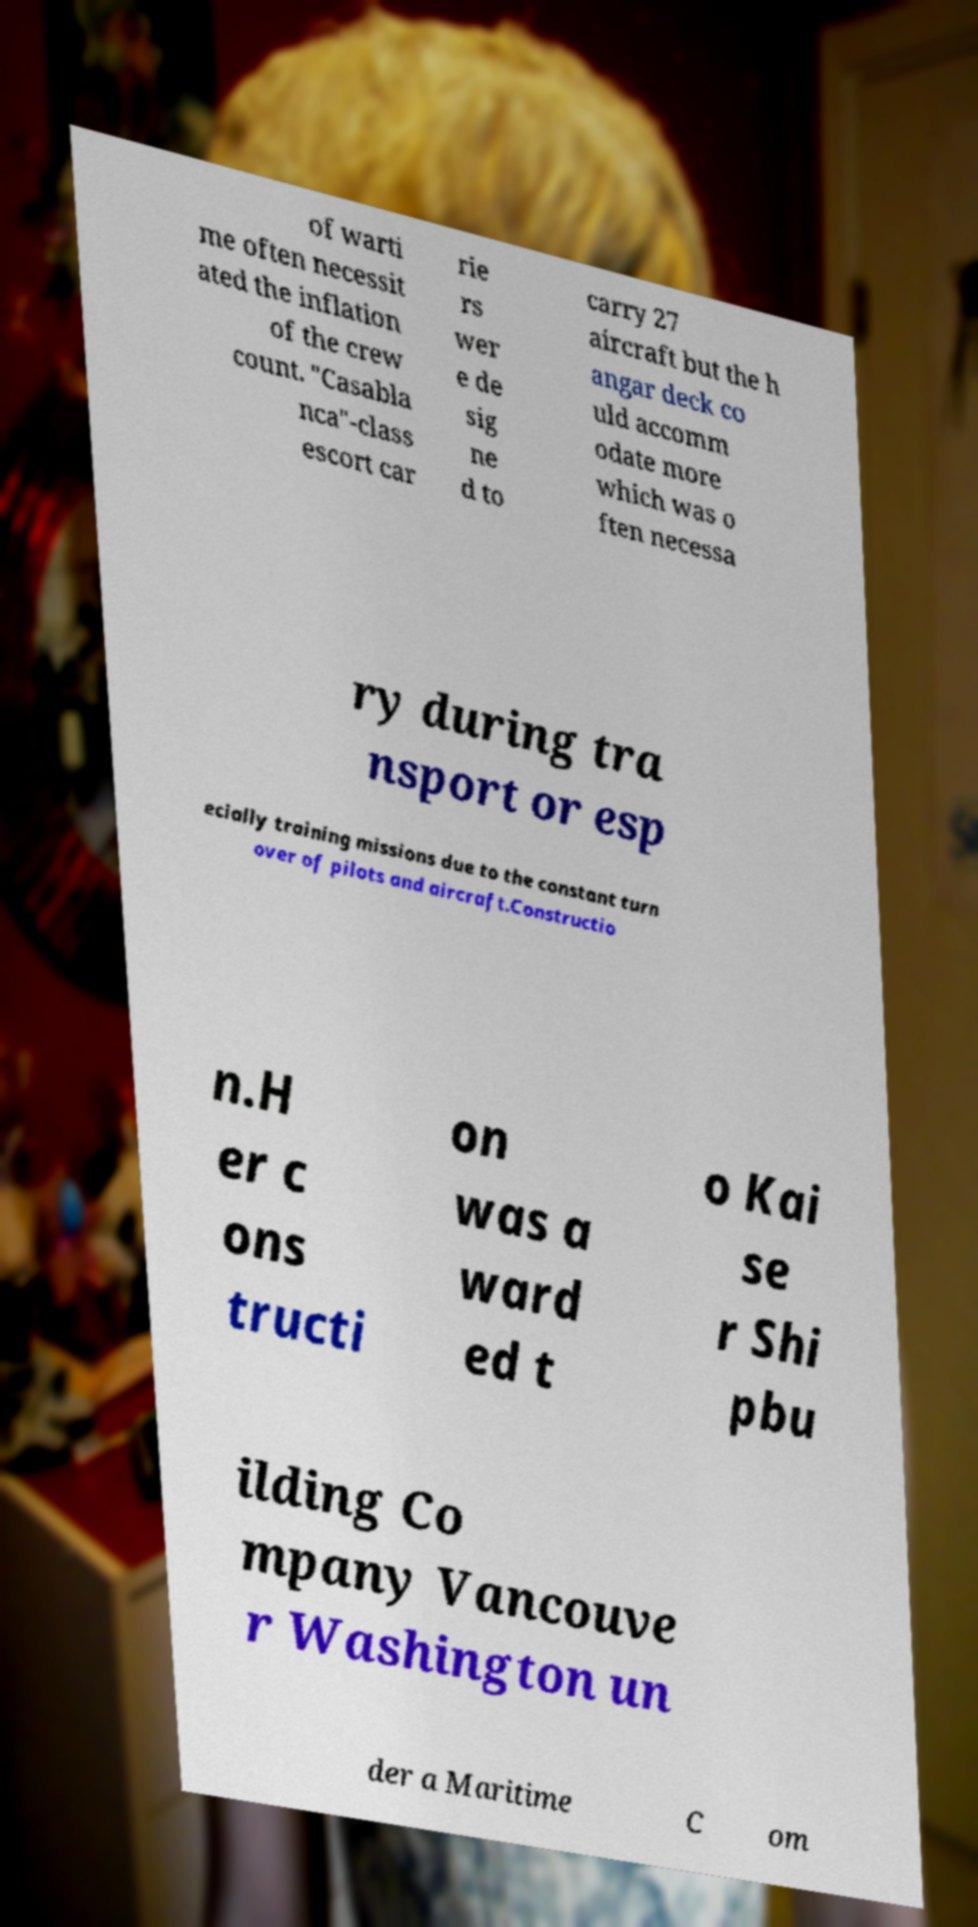Can you accurately transcribe the text from the provided image for me? of warti me often necessit ated the inflation of the crew count. "Casabla nca"-class escort car rie rs wer e de sig ne d to carry 27 aircraft but the h angar deck co uld accomm odate more which was o ften necessa ry during tra nsport or esp ecially training missions due to the constant turn over of pilots and aircraft.Constructio n.H er c ons tructi on was a ward ed t o Kai se r Shi pbu ilding Co mpany Vancouve r Washington un der a Maritime C om 